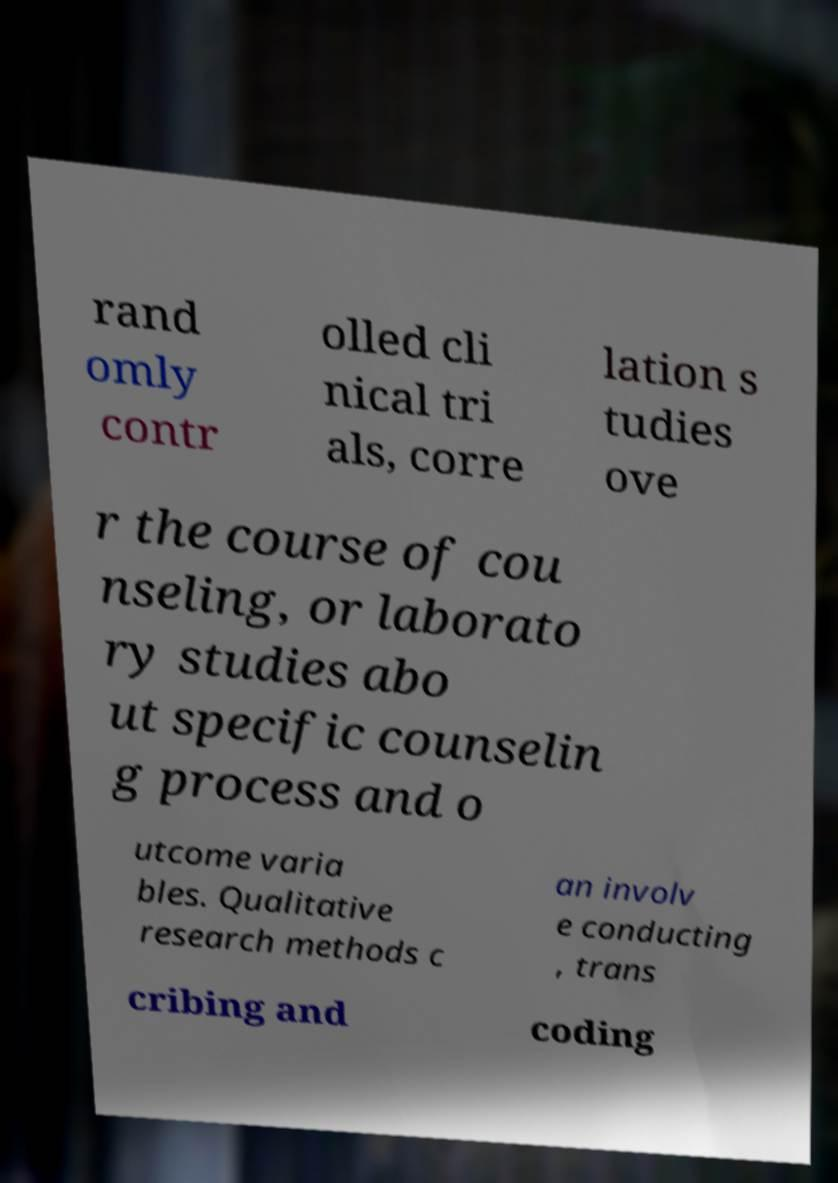For documentation purposes, I need the text within this image transcribed. Could you provide that? rand omly contr olled cli nical tri als, corre lation s tudies ove r the course of cou nseling, or laborato ry studies abo ut specific counselin g process and o utcome varia bles. Qualitative research methods c an involv e conducting , trans cribing and coding 